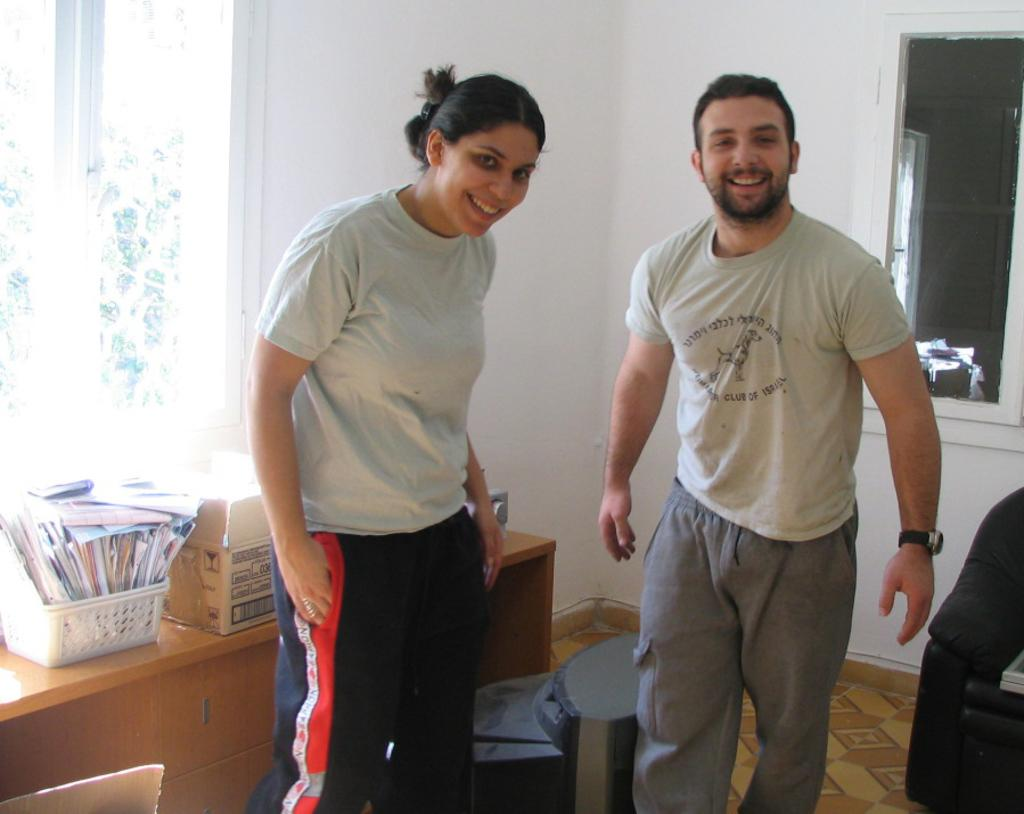Who is present in the image? There is a woman and a man in the image. What are the woman and the man doing in the image? Both the woman and the man are standing, and they have smiles on their faces. What can be seen in the background of the image? There is a box and papers on a table in the background of the image. What type of chalk is being used by the woman in the image? There is no chalk present in the image; the woman and the man are simply standing and smiling. 